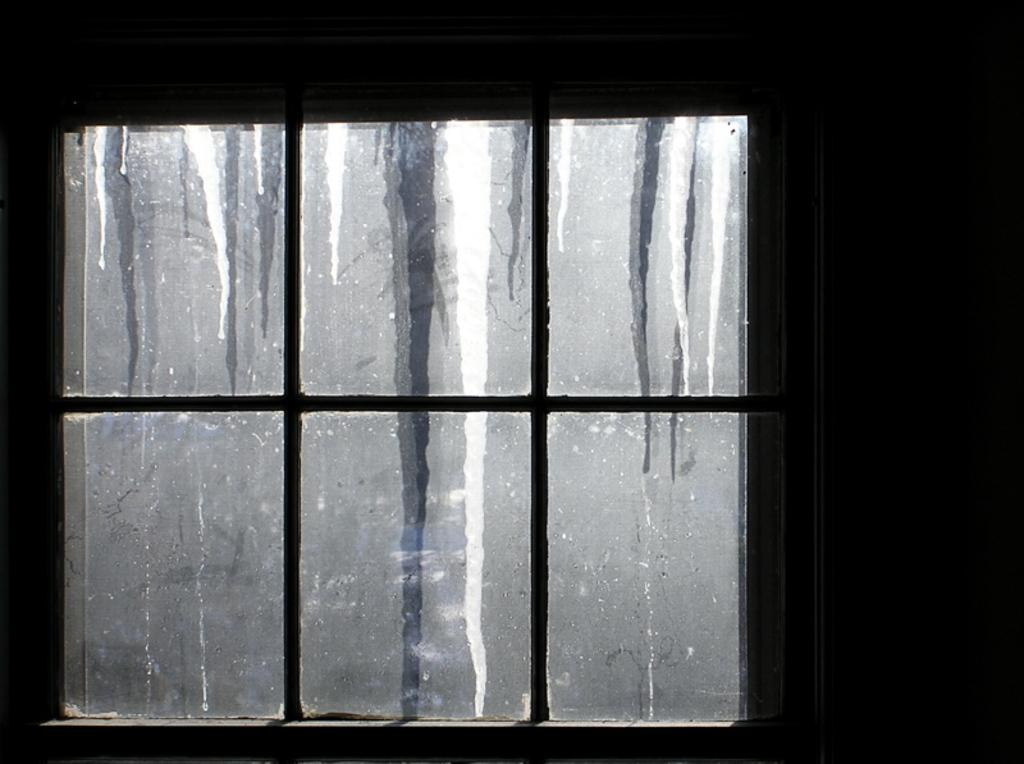What object in the image looks like a window? There is an object in the image that resembles a window. What can be used for cooking in the image? There is a grill visible in the image. What type of powder is being used to clean the grill in the image? There is no powder visible in the image, and the grill is not being cleaned. 